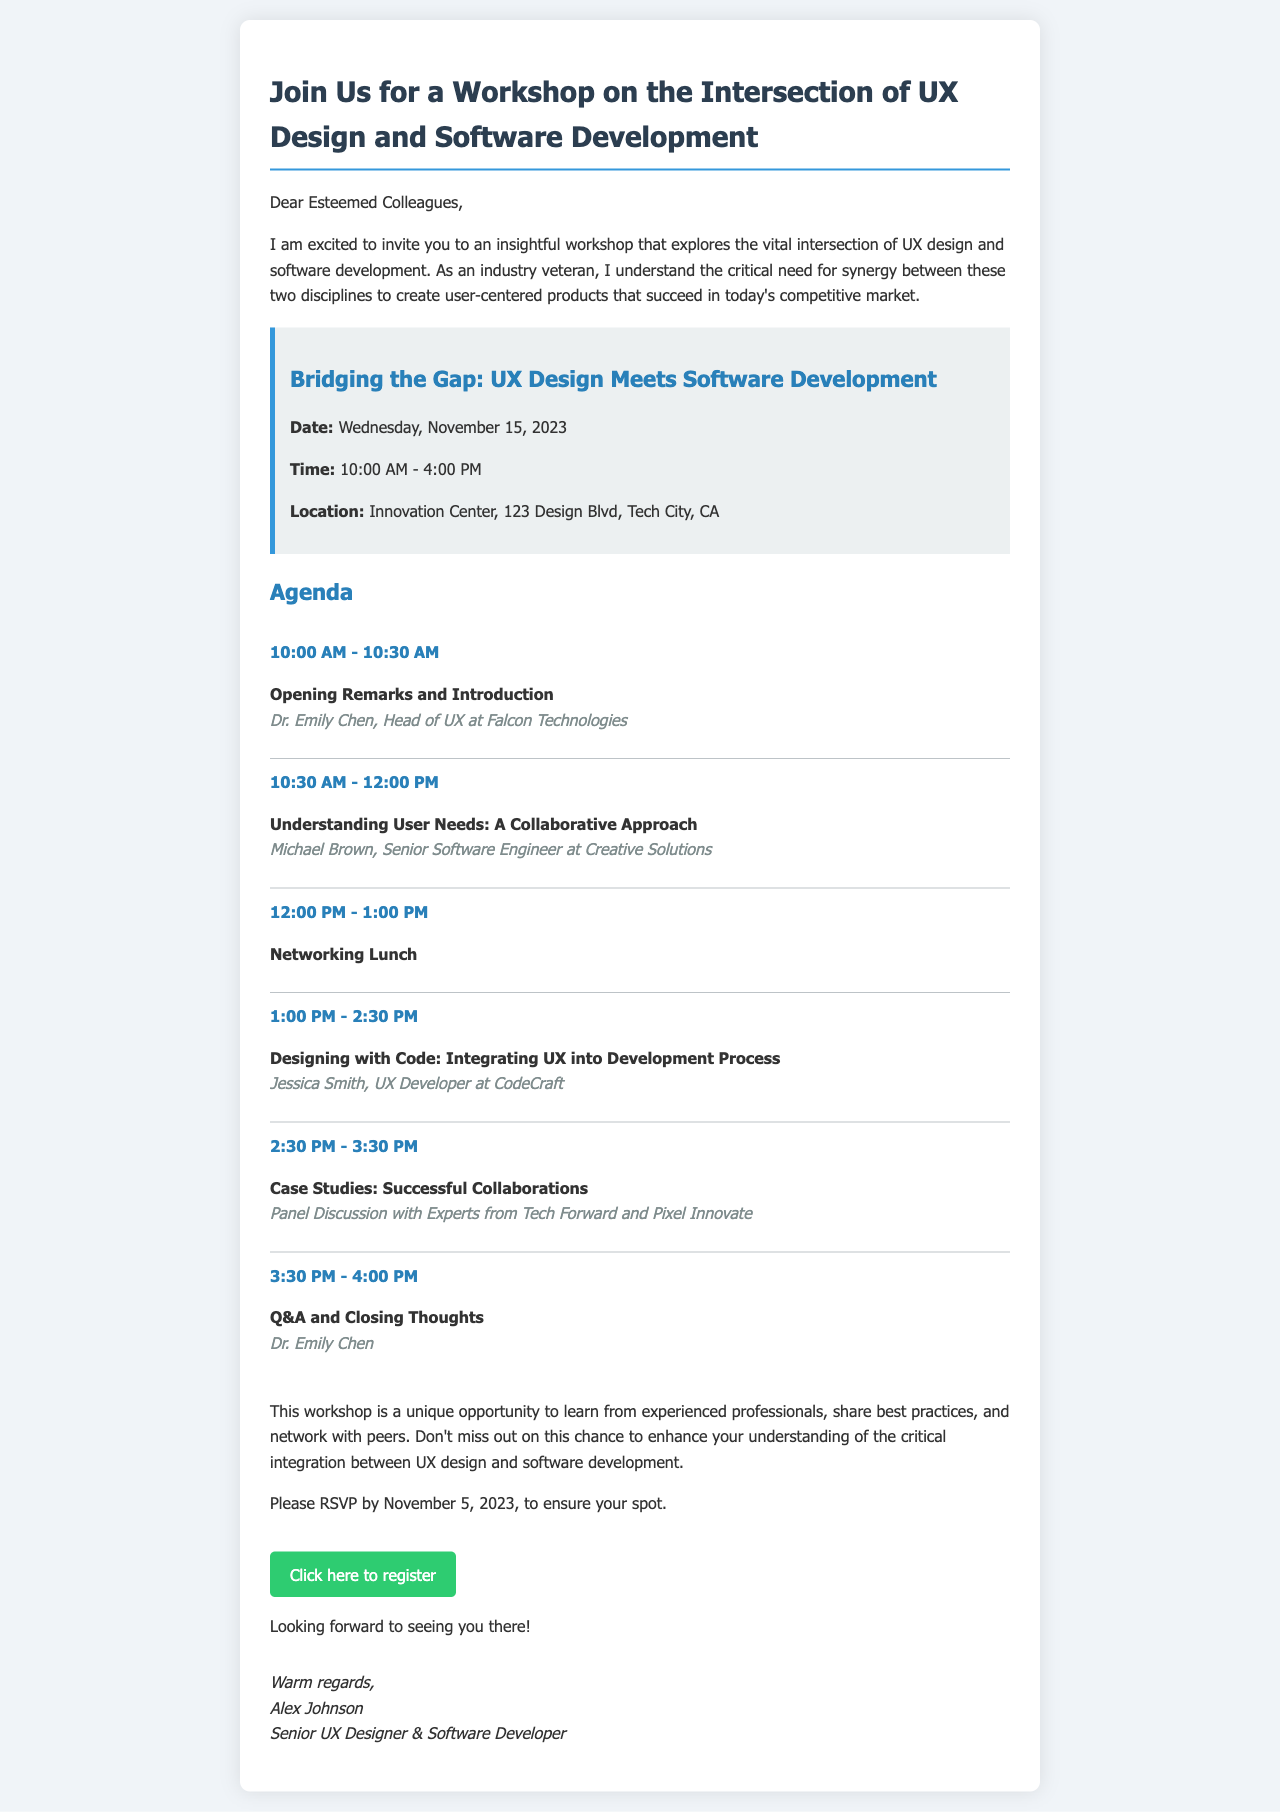What is the date of the workshop? The workshop is scheduled for Wednesday, November 15, 2023, as stated in the document.
Answer: November 15, 2023 What time does the workshop start? The document specifies that the workshop starts at 10:00 AM.
Answer: 10:00 AM Who is the speaker for the opening remarks? The document lists Dr. Emily Chen as the speaker for the opening remarks.
Answer: Dr. Emily Chen What is the location of the event? The location mentioned in the document is the Innovation Center, 123 Design Blvd, Tech City, CA.
Answer: Innovation Center, 123 Design Blvd, Tech City, CA When is the RSVP deadline? The document states that RSVP is due by November 5, 2023.
Answer: November 5, 2023 What type of event is being hosted? The document indicates it is a workshop focused on the intersection of UX design and software development.
Answer: Workshop Which session covers "Designing with Code"? According to the agenda, the session titled "Designing with Code: Integrating UX into Development Process" covers that topic.
Answer: Designing with Code: Integrating UX into Development Process How long is the networking lunch? The agenda specifies that the networking lunch is from 12:00 PM to 1:00 PM, which is one hour long.
Answer: 1 hour How many items are listed in the agenda? The document outlines a total of six agenda items for the event.
Answer: Six 